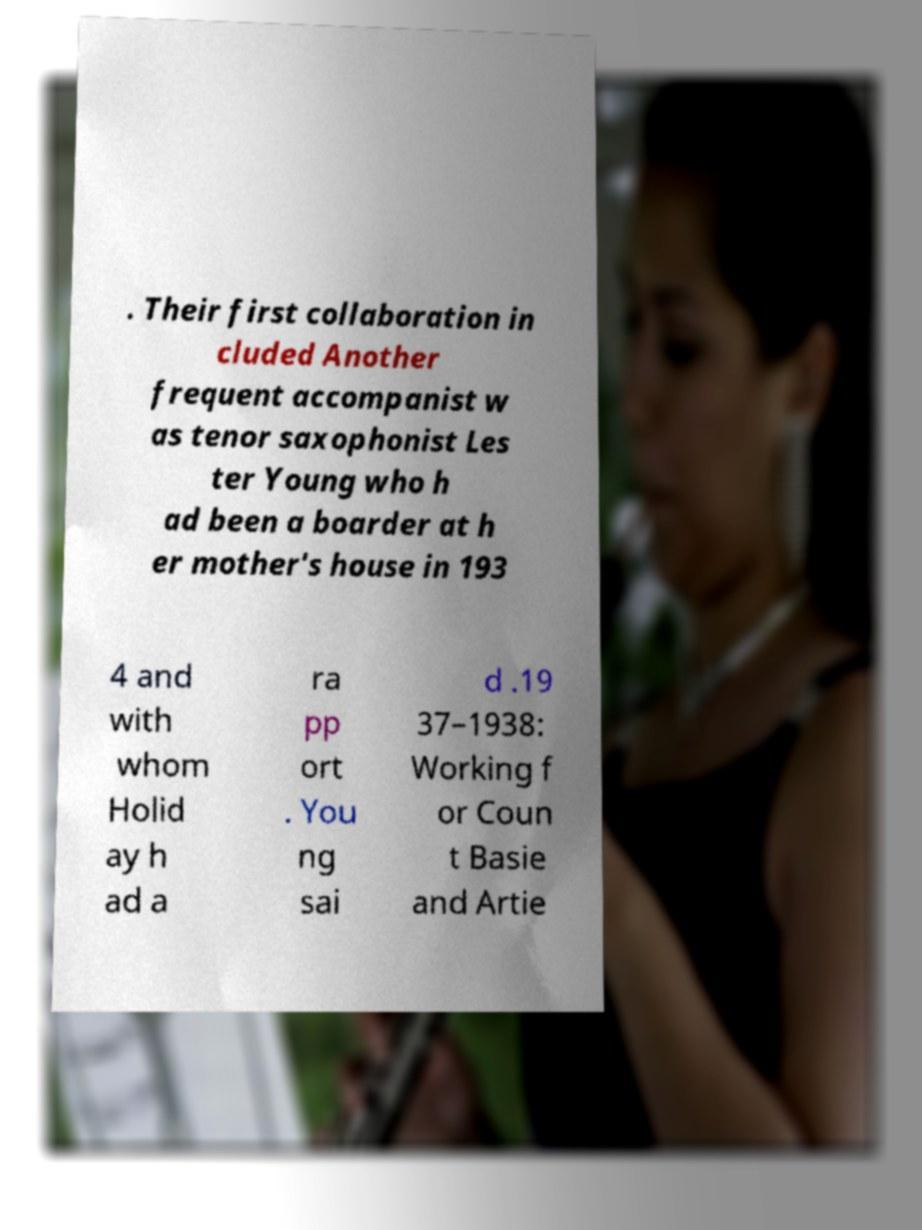What messages or text are displayed in this image? I need them in a readable, typed format. . Their first collaboration in cluded Another frequent accompanist w as tenor saxophonist Les ter Young who h ad been a boarder at h er mother's house in 193 4 and with whom Holid ay h ad a ra pp ort . You ng sai d .19 37–1938: Working f or Coun t Basie and Artie 